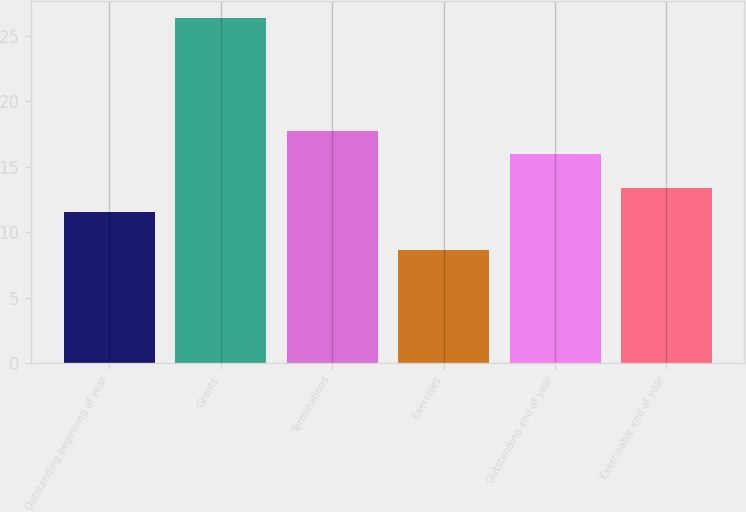Convert chart to OTSL. <chart><loc_0><loc_0><loc_500><loc_500><bar_chart><fcel>Outstanding beginning of year<fcel>Grants<fcel>Terminations<fcel>Exercises<fcel>Outstanding end of year<fcel>Exercisable end of year<nl><fcel>11.57<fcel>26.37<fcel>17.76<fcel>8.6<fcel>15.98<fcel>13.35<nl></chart> 